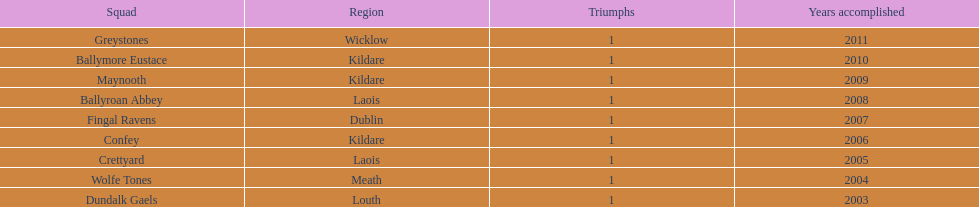Can you give me this table as a dict? {'header': ['Squad', 'Region', 'Triumphs', 'Years accomplished'], 'rows': [['Greystones', 'Wicklow', '1', '2011'], ['Ballymore Eustace', 'Kildare', '1', '2010'], ['Maynooth', 'Kildare', '1', '2009'], ['Ballyroan Abbey', 'Laois', '1', '2008'], ['Fingal Ravens', 'Dublin', '1', '2007'], ['Confey', 'Kildare', '1', '2006'], ['Crettyard', 'Laois', '1', '2005'], ['Wolfe Tones', 'Meath', '1', '2004'], ['Dundalk Gaels', 'Louth', '1', '2003']]} Which team won after ballymore eustace? Greystones. 